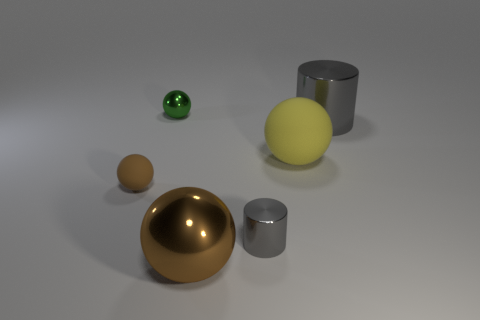Subtract 1 balls. How many balls are left? 3 Subtract all gray spheres. Subtract all cyan cylinders. How many spheres are left? 4 Add 1 small green balls. How many objects exist? 7 Subtract all spheres. How many objects are left? 2 Subtract 0 yellow cylinders. How many objects are left? 6 Subtract all gray shiny cylinders. Subtract all green shiny blocks. How many objects are left? 4 Add 4 big cylinders. How many big cylinders are left? 5 Add 2 tiny yellow balls. How many tiny yellow balls exist? 2 